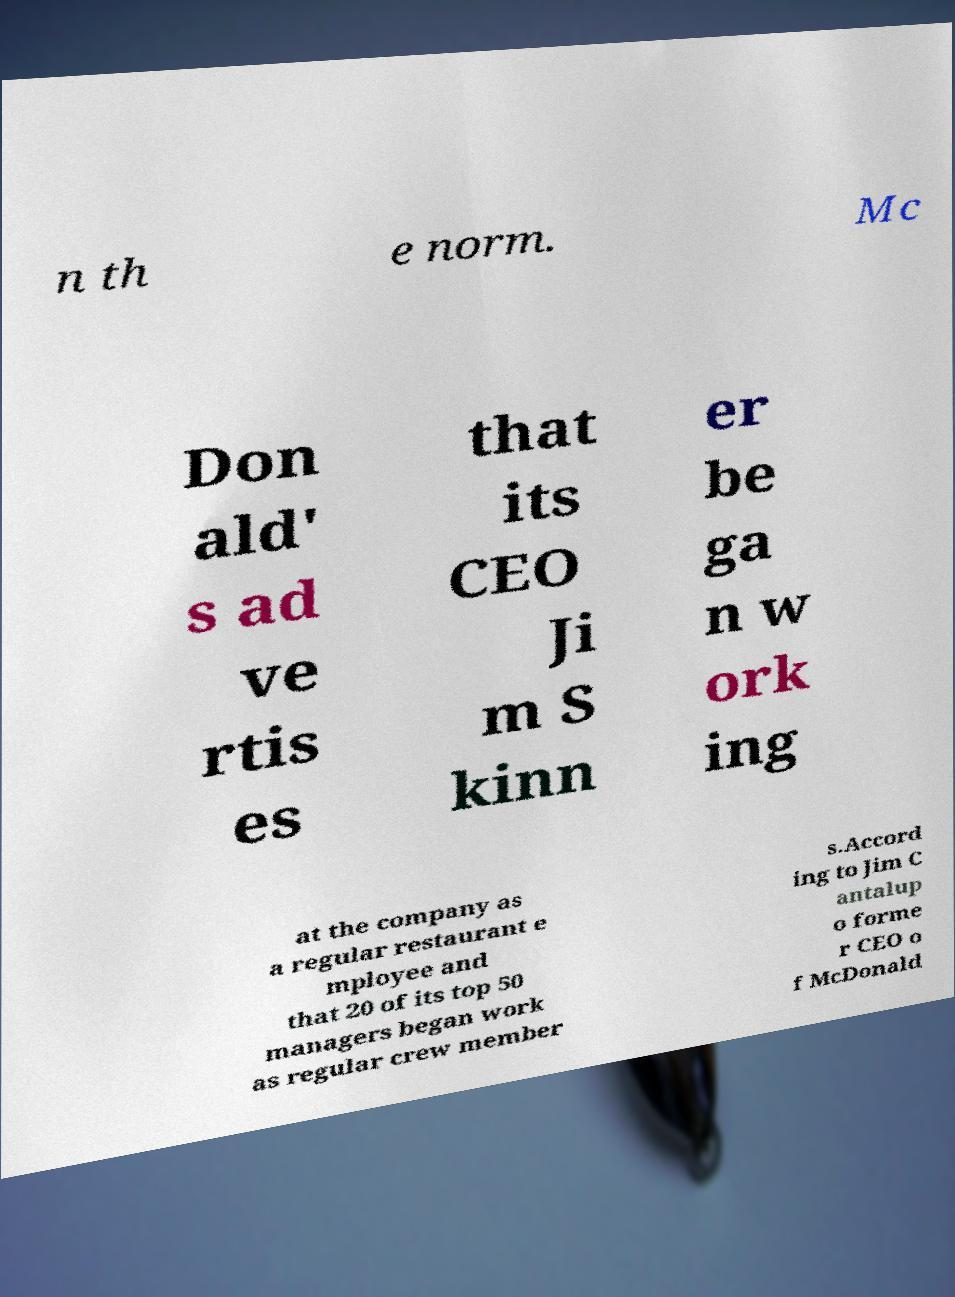Could you extract and type out the text from this image? n th e norm. Mc Don ald' s ad ve rtis es that its CEO Ji m S kinn er be ga n w ork ing at the company as a regular restaurant e mployee and that 20 of its top 50 managers began work as regular crew member s.Accord ing to Jim C antalup o forme r CEO o f McDonald 